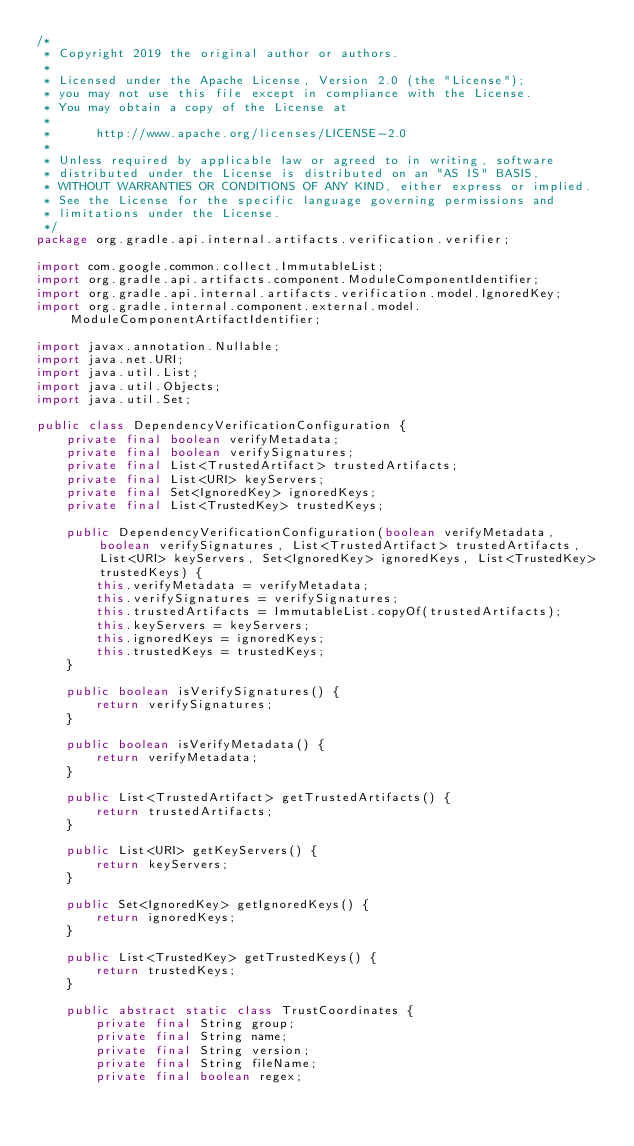<code> <loc_0><loc_0><loc_500><loc_500><_Java_>/*
 * Copyright 2019 the original author or authors.
 *
 * Licensed under the Apache License, Version 2.0 (the "License");
 * you may not use this file except in compliance with the License.
 * You may obtain a copy of the License at
 *
 *      http://www.apache.org/licenses/LICENSE-2.0
 *
 * Unless required by applicable law or agreed to in writing, software
 * distributed under the License is distributed on an "AS IS" BASIS,
 * WITHOUT WARRANTIES OR CONDITIONS OF ANY KIND, either express or implied.
 * See the License for the specific language governing permissions and
 * limitations under the License.
 */
package org.gradle.api.internal.artifacts.verification.verifier;

import com.google.common.collect.ImmutableList;
import org.gradle.api.artifacts.component.ModuleComponentIdentifier;
import org.gradle.api.internal.artifacts.verification.model.IgnoredKey;
import org.gradle.internal.component.external.model.ModuleComponentArtifactIdentifier;

import javax.annotation.Nullable;
import java.net.URI;
import java.util.List;
import java.util.Objects;
import java.util.Set;

public class DependencyVerificationConfiguration {
    private final boolean verifyMetadata;
    private final boolean verifySignatures;
    private final List<TrustedArtifact> trustedArtifacts;
    private final List<URI> keyServers;
    private final Set<IgnoredKey> ignoredKeys;
    private final List<TrustedKey> trustedKeys;

    public DependencyVerificationConfiguration(boolean verifyMetadata, boolean verifySignatures, List<TrustedArtifact> trustedArtifacts, List<URI> keyServers, Set<IgnoredKey> ignoredKeys, List<TrustedKey> trustedKeys) {
        this.verifyMetadata = verifyMetadata;
        this.verifySignatures = verifySignatures;
        this.trustedArtifacts = ImmutableList.copyOf(trustedArtifacts);
        this.keyServers = keyServers;
        this.ignoredKeys = ignoredKeys;
        this.trustedKeys = trustedKeys;
    }

    public boolean isVerifySignatures() {
        return verifySignatures;
    }

    public boolean isVerifyMetadata() {
        return verifyMetadata;
    }

    public List<TrustedArtifact> getTrustedArtifacts() {
        return trustedArtifacts;
    }

    public List<URI> getKeyServers() {
        return keyServers;
    }

    public Set<IgnoredKey> getIgnoredKeys() {
        return ignoredKeys;
    }

    public List<TrustedKey> getTrustedKeys() {
        return trustedKeys;
    }

    public abstract static class TrustCoordinates {
        private final String group;
        private final String name;
        private final String version;
        private final String fileName;
        private final boolean regex;
</code> 